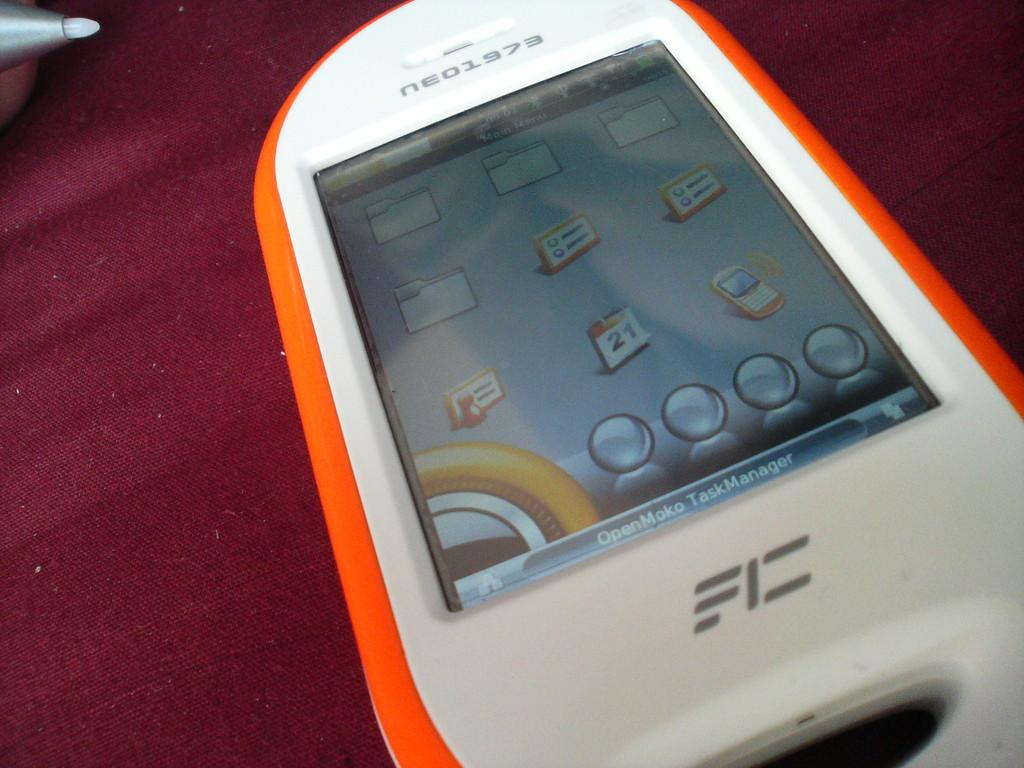<image>
Create a compact narrative representing the image presented. orange and white cell phone that has neo1973 at top of it on a wooden surface 